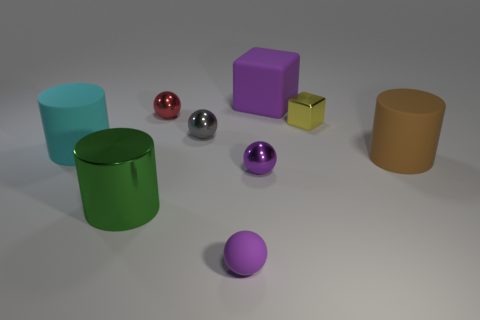There is a matte sphere that is the same color as the matte block; what is its size?
Ensure brevity in your answer.  Small. What material is the other large thing that is the same shape as the yellow metal thing?
Keep it short and to the point. Rubber. What number of cyan objects are either large cylinders or tiny balls?
Offer a very short reply. 1. Is there any other thing of the same color as the metal block?
Make the answer very short. No. The big thing behind the big matte cylinder left of the big purple rubber thing is what color?
Keep it short and to the point. Purple. Is the number of tiny blocks in front of the cyan matte thing less than the number of big brown matte objects that are to the left of the small gray thing?
Offer a terse response. No. There is a sphere that is the same color as the tiny matte object; what is its material?
Keep it short and to the point. Metal. How many objects are either small yellow things that are behind the purple rubber ball or big brown things?
Your response must be concise. 2. There is a rubber object in front of the metallic cylinder; does it have the same size as the large purple matte cube?
Provide a short and direct response. No. Are there fewer rubber blocks that are on the left side of the large metal thing than metal objects?
Ensure brevity in your answer.  Yes. 